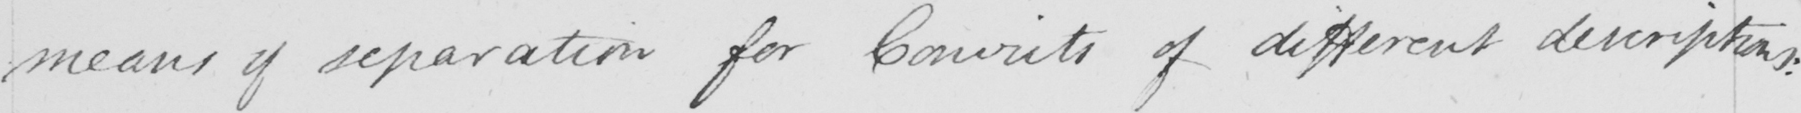Can you tell me what this handwritten text says? means of separation for Convicts of different descriptions : 